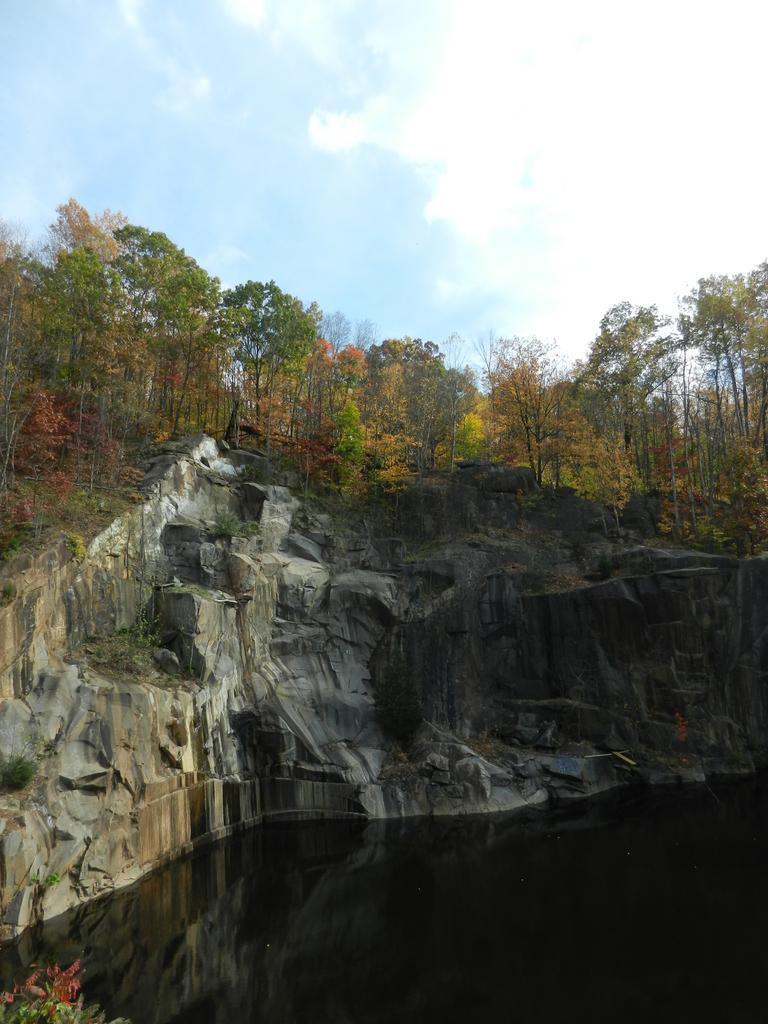What is the primary element in the image? There is water in the image. What other objects or features can be seen in the image? There are rocks and many trees in the image. What can be seen in the background of the image? There are clouds visible in the background of the image, and the sky is blue. Where are the cherries located in the image? There are no cherries present in the image. What type of riddle can be solved by looking at the image? There is no riddle associated with the image; it simply depicts water, rocks, trees, clouds, and a blue sky. 